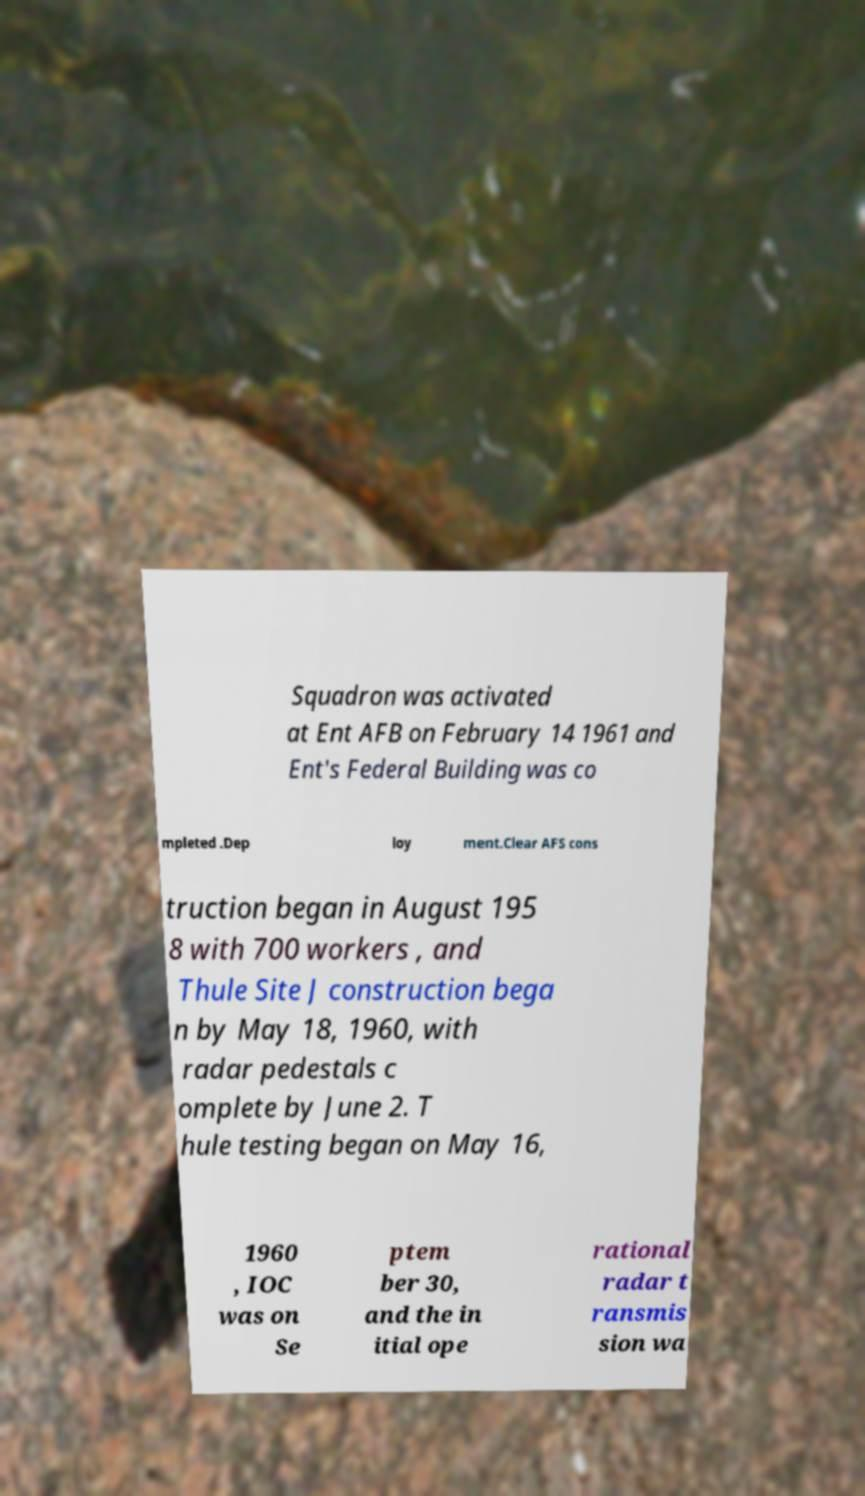Please identify and transcribe the text found in this image. Squadron was activated at Ent AFB on February 14 1961 and Ent's Federal Building was co mpleted .Dep loy ment.Clear AFS cons truction began in August 195 8 with 700 workers , and Thule Site J construction bega n by May 18, 1960, with radar pedestals c omplete by June 2. T hule testing began on May 16, 1960 , IOC was on Se ptem ber 30, and the in itial ope rational radar t ransmis sion wa 